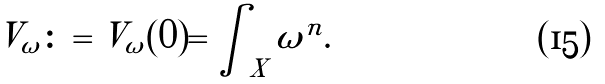<formula> <loc_0><loc_0><loc_500><loc_500>V _ { \omega } \colon = V _ { \omega } ( 0 ) = \int _ { X } \omega ^ { n } .</formula> 